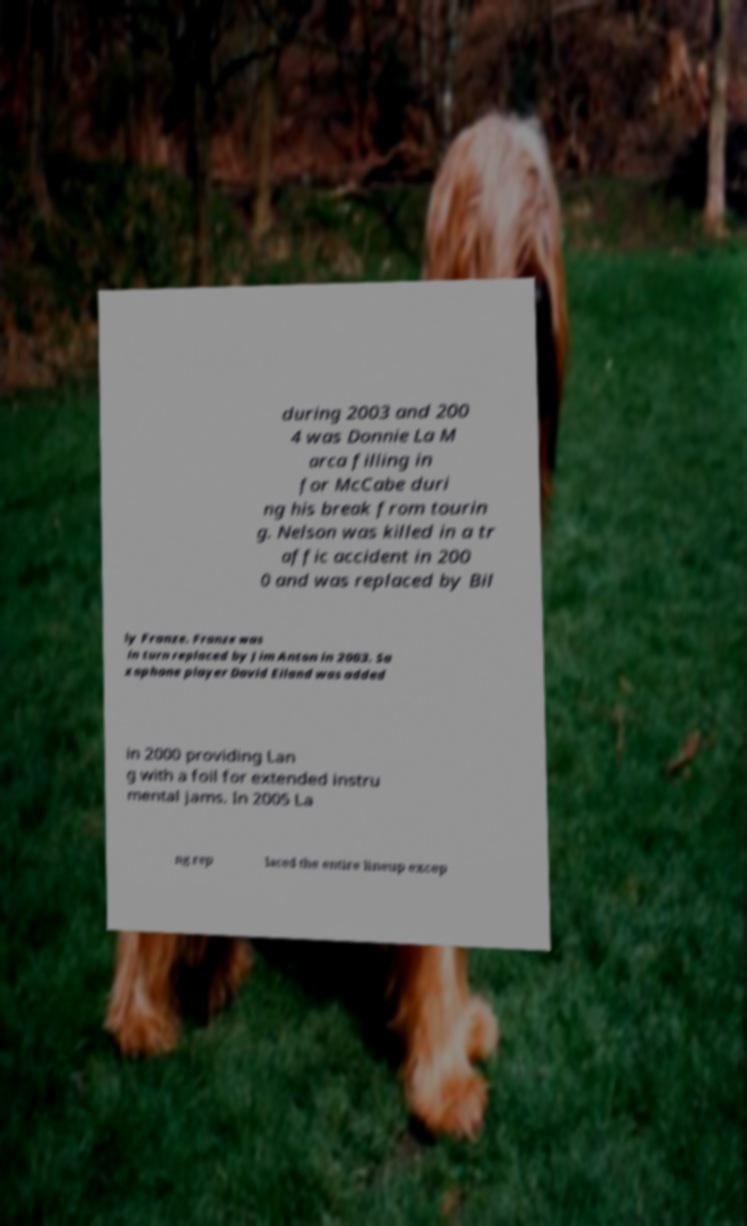Could you assist in decoding the text presented in this image and type it out clearly? during 2003 and 200 4 was Donnie La M arca filling in for McCabe duri ng his break from tourin g. Nelson was killed in a tr affic accident in 200 0 and was replaced by Bil ly Franze. Franze was in turn replaced by Jim Anton in 2003. Sa xophone player David Eiland was added in 2000 providing Lan g with a foil for extended instru mental jams. In 2005 La ng rep laced the entire lineup excep 